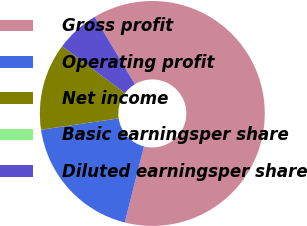Convert chart to OTSL. <chart><loc_0><loc_0><loc_500><loc_500><pie_chart><fcel>Gross profit<fcel>Operating profit<fcel>Net income<fcel>Basic earningsper share<fcel>Diluted earningsper share<nl><fcel>62.5%<fcel>18.75%<fcel>12.5%<fcel>0.0%<fcel>6.25%<nl></chart> 